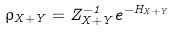Convert formula to latex. <formula><loc_0><loc_0><loc_500><loc_500>\rho _ { X + Y } = Z _ { X + Y } ^ { - 1 } e ^ { - H _ { X + Y } }</formula> 